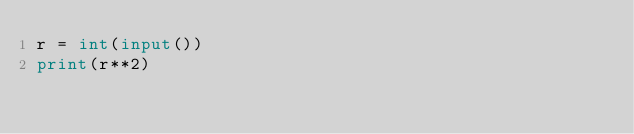Convert code to text. <code><loc_0><loc_0><loc_500><loc_500><_Python_>r = int(input())
print(r**2)</code> 